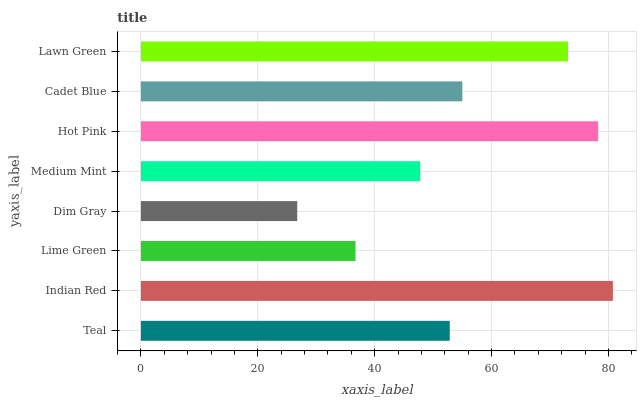Is Dim Gray the minimum?
Answer yes or no. Yes. Is Indian Red the maximum?
Answer yes or no. Yes. Is Lime Green the minimum?
Answer yes or no. No. Is Lime Green the maximum?
Answer yes or no. No. Is Indian Red greater than Lime Green?
Answer yes or no. Yes. Is Lime Green less than Indian Red?
Answer yes or no. Yes. Is Lime Green greater than Indian Red?
Answer yes or no. No. Is Indian Red less than Lime Green?
Answer yes or no. No. Is Cadet Blue the high median?
Answer yes or no. Yes. Is Teal the low median?
Answer yes or no. Yes. Is Medium Mint the high median?
Answer yes or no. No. Is Cadet Blue the low median?
Answer yes or no. No. 